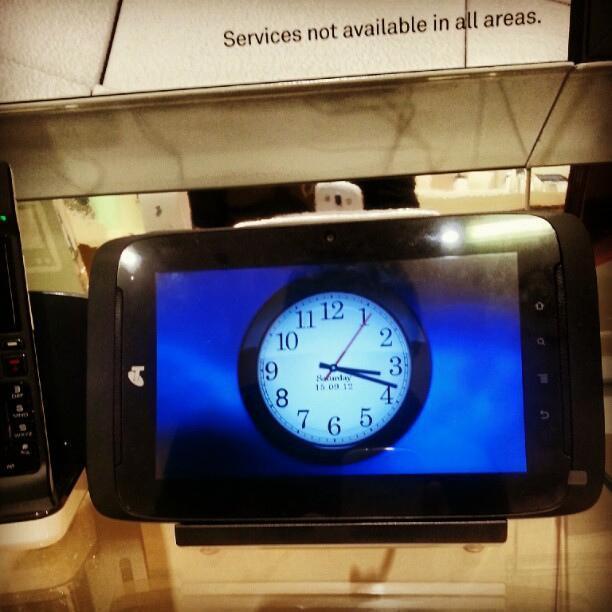What numbered day of the week is it?
Choose the correct response, then elucidate: 'Answer: answer
Rationale: rationale.'
Options: Two, three, five, seven. Answer: seven.
Rationale: It is a sunday on the clock. 